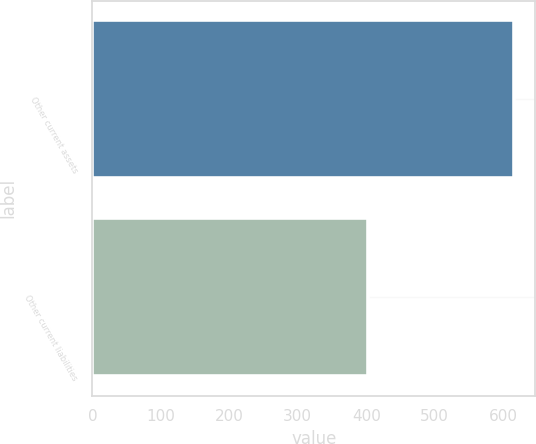Convert chart. <chart><loc_0><loc_0><loc_500><loc_500><bar_chart><fcel>Other current assets<fcel>Other current liabilities<nl><fcel>616<fcel>402<nl></chart> 